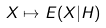Convert formula to latex. <formula><loc_0><loc_0><loc_500><loc_500>X \mapsto E ( X | H )</formula> 